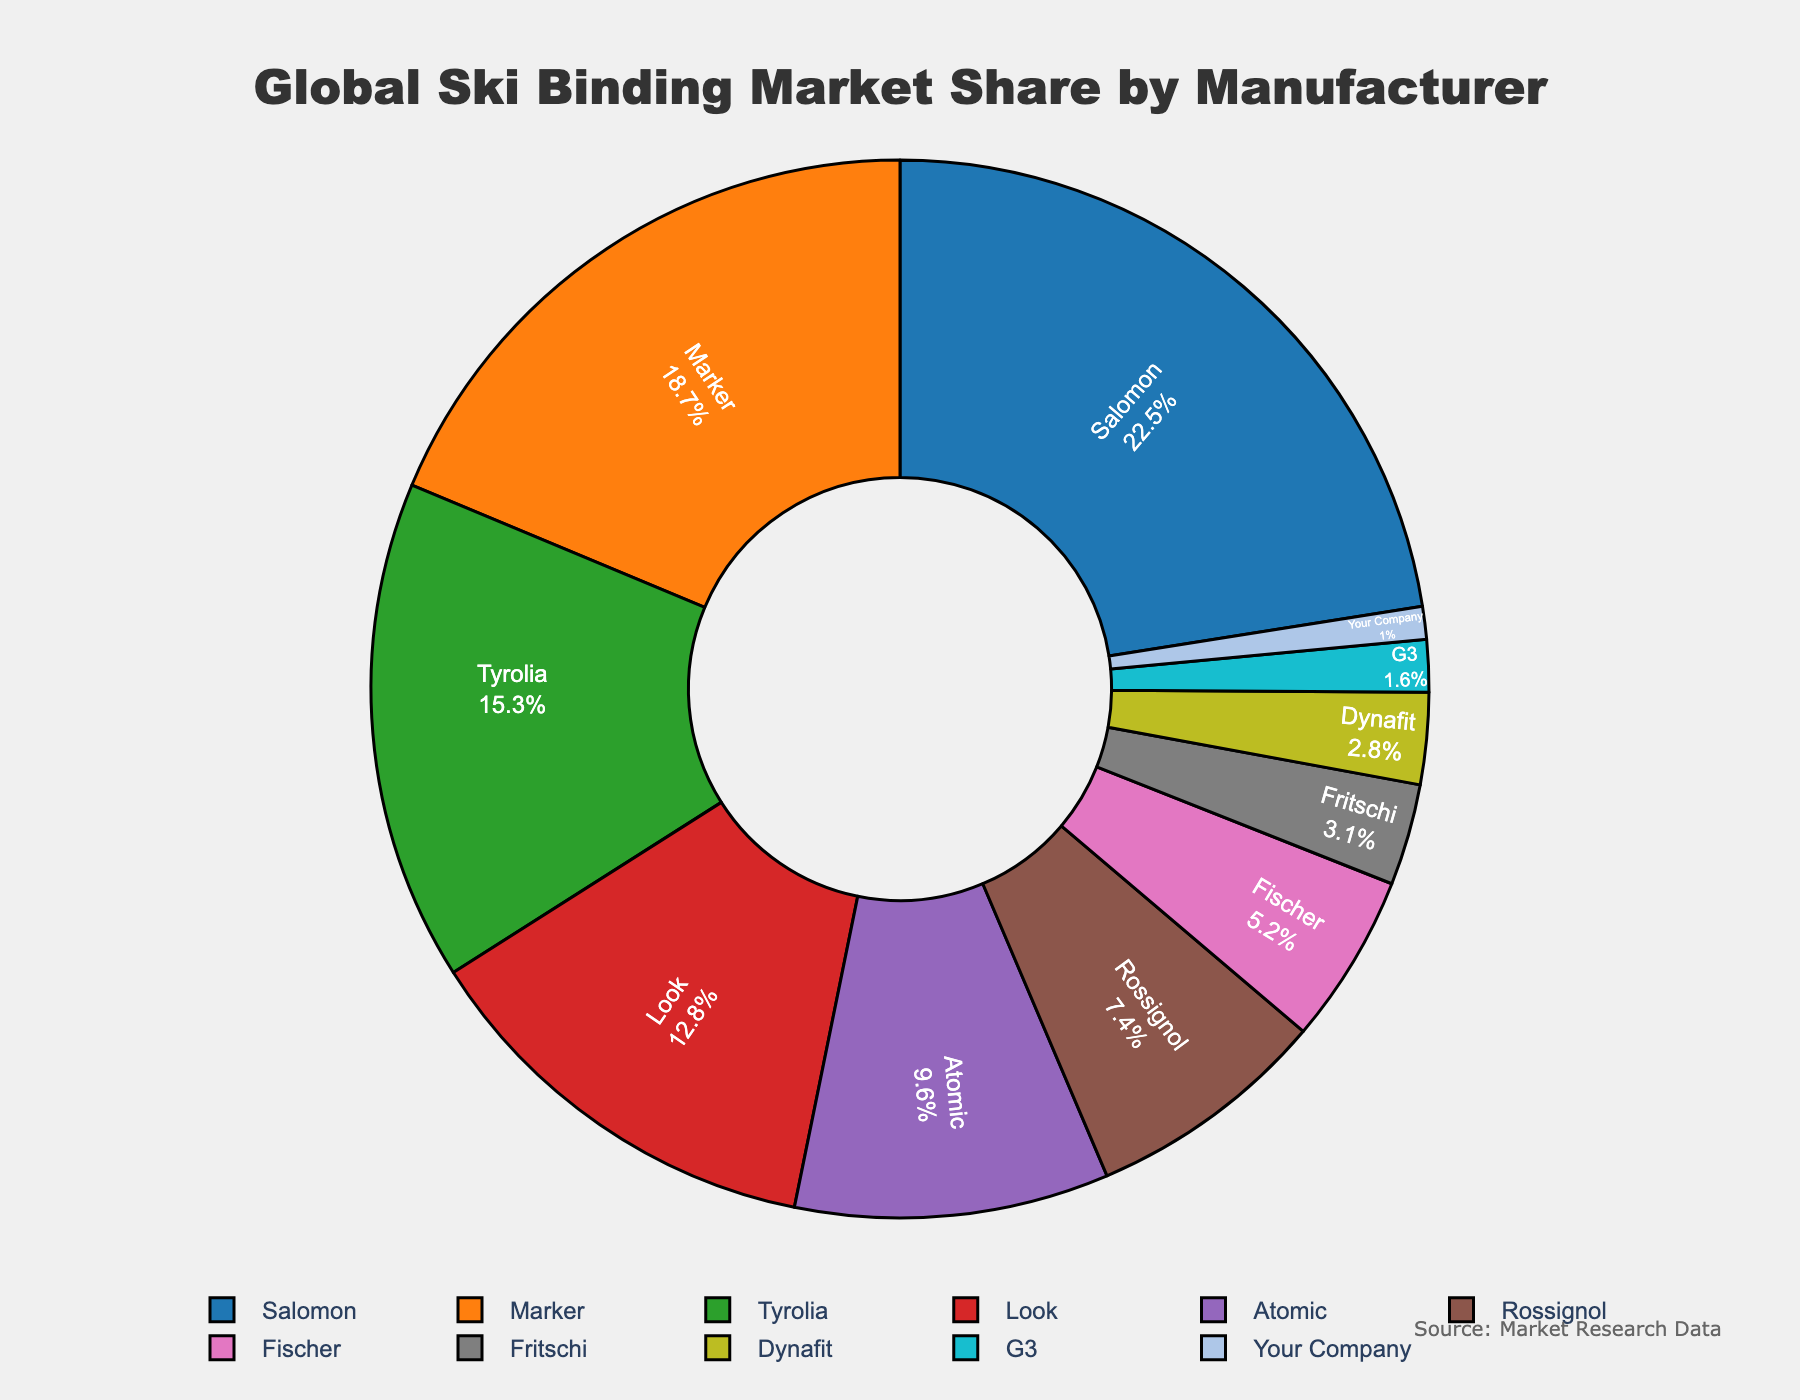What is the market share of the top three manufacturers combined? Sum the market shares of the top three manufacturers: Salomon (22.5), Marker (18.7), and Tyrolia (15.3). So, 22.5 + 18.7 + 15.3 = 56.5
Answer: 56.5% Which manufacturer has the smallest market share, and what is it? Look for the manufacturer with the smallest segment in the pie chart, which corresponds to "Your Company" with a market share of 1.0%
Answer: Your Company, 1.0% Which manufacturers have a market share greater than 10%? Identify segments of the pie chart with greater than 10% market share: Salomon (22.5), Marker (18.7), Tyrolia (15.3), and Look (12.8)
Answer: Salomon, Marker, Tyrolia, Look How does the market share of Atomic compare to that of Rossignol? Compare the values for Atomic (9.6%) and Rossignol (7.4%). Since 9.6 > 7.4, Atomic has a larger market share.
Answer: Atomic has a greater market share than Rossignol What is the combined market share of manufacturers with less than 5% market share? Sum the market shares of manufacturers with less than 5%: Fischer (5.2), Fritschi (3.1), Dynafit (2.8), G3 (1.6), Your Company (1.0). Note: Fischer should not be included as its market share is 5.2, more than 5. So, 3.1 + 2.8 + 1.6 + 1.0 = 8.5
Answer: 8.5% What percentage of the market share is taken by manufacturers other than the top five? Subtract the sum of the top five manufacturers' market shares from 100%: Salomon (22.5), Marker (18.7), Tyrolia (15.3), Look (12.8), Atomic (9.6). First sum them, 22.5 + 18.7 + 15.3 + 12.8 + 9.6 = 78.9. Then, 100 - 78.9 = 21.1
Answer: 21.1% What is the difference in market share between the manufacturer with the highest share and the manufacturer with the lowest share? Subtract the market share of the lowest manufacturer from that of the highest: Salomon (22.5) - Your Company (1.0) = 21.5
Answer: 21.5% What is the average market share of Rossignol, Fischer, Fritschi, and Dynafit? Sum their market shares and divide by 4: (Rossignol 7.4 + Fischer 5.2 + Fritschi 3.1 + Dynafit 2.8) / 4 = 18.5 / 4 = 4.625
Answer: 4.625% Which color represents Marker manufacturer in the pie chart? The custom color palette assigns colors in order to the manufacturers. Marker being the second can be identified with the second color in the legend, which is orange.
Answer: Orange 